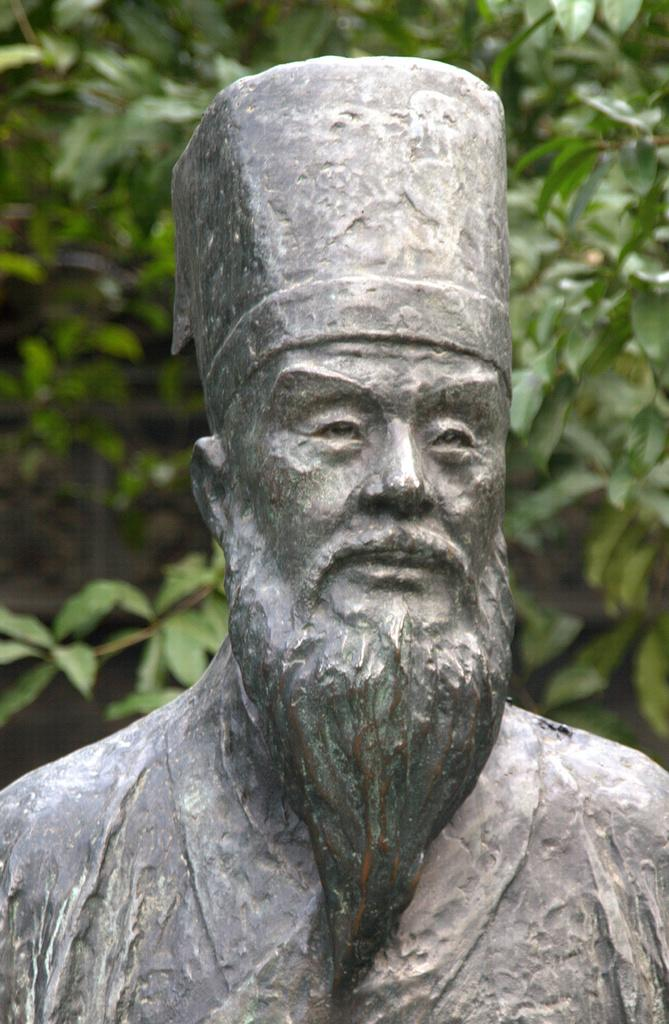What is the main subject in the image? There is a statue in the image. Can you describe the background of the image? The background of the image is blurred. What type of vegetation can be seen in the image? Plant leaves are present in the image. How many hands does the scarecrow have in the image? There is no scarecrow present in the image, so it is not possible to determine the number of hands it might have. 